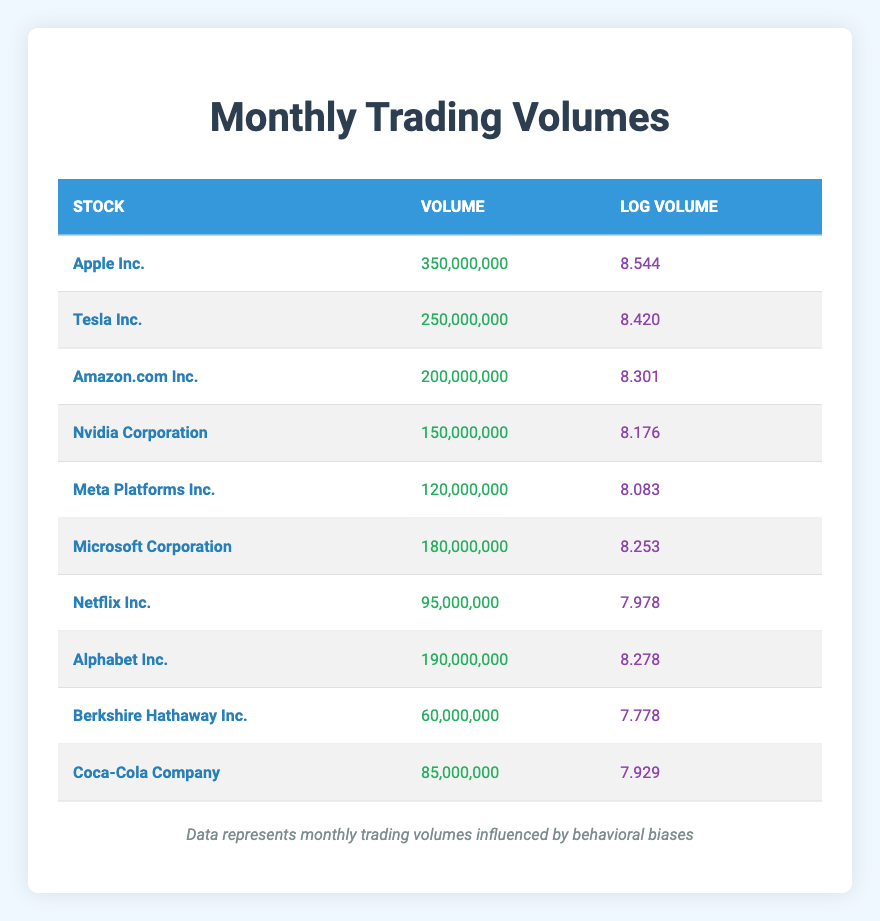What is the monthly trading volume of Apple Inc.? The table lists Apple Inc. with a trading volume of 350,000,000.
Answer: 350,000,000 Which stock has the highest log volume? From the table, Apple Inc. has the highest log volume of 8.544.
Answer: Apple Inc What is the combined trading volume of Alphabet Inc. and Meta Platforms Inc.? Adding their volumes gives us 190,000,000 (Alphabet Inc.) + 120,000,000 (Meta Platforms Inc.) = 310,000,000.
Answer: 310,000,000 Is the trading volume of Nvidia Corporation greater than that of Netflix Inc.? According to the table, Nvidia Corporation has a trading volume of 150,000,000 while Netflix Inc. has 95,000,000, making the statement true.
Answer: Yes What is the average trading volume of stocks listed in the table? To find the average, sum the volumes: 350,000,000 + 250,000,000 + 200,000,000 + 150,000,000 + 120,000,000 + 180,000,000 + 95,000,000 + 190,000,000 + 60,000,000 + 85,000,000 = 1,680,000,000. Then divide by the number of stocks (10), which results in 1,680,000,000 / 10 = 168,000,000.
Answer: 168,000,000 How many stocks have a trading volume greater than 100 million? The table shows 6 stocks (Apple Inc., Tesla Inc., Amazon.com Inc., Microsoft Corporation, Alphabet Inc., and Meta Platforms Inc.) with volumes greater than 100 million.
Answer: 6 What is the difference in log volume between Tesla Inc. and Nvidia Corporation? The log volume for Tesla Inc. is 8.420 and for Nvidia Corporation is 8.176. The difference is 8.420 - 8.176 = 0.244.
Answer: 0.244 Is the trading volume of Coca-Cola Company less than that of Berkshire Hathaway Inc.? The table indicates Coca-Cola Company has a volume of 85,000,000 and Berkshire Hathaway Inc. has 60,000,000, thus the statement is false.
Answer: No Which stock has the lowest trading volume? Referring to the table, Berkshire Hathaway Inc. has the lowest volume of 60,000,000.
Answer: Berkshire Hathaway Inc What are the log volumes of Apple Inc. and Amazon.com Inc. combined? The log volume of Apple Inc. is 8.544 and that of Amazon.com Inc. is 8.301. The combined log volume is 8.544 + 8.301 = 16.845.
Answer: 16.845 